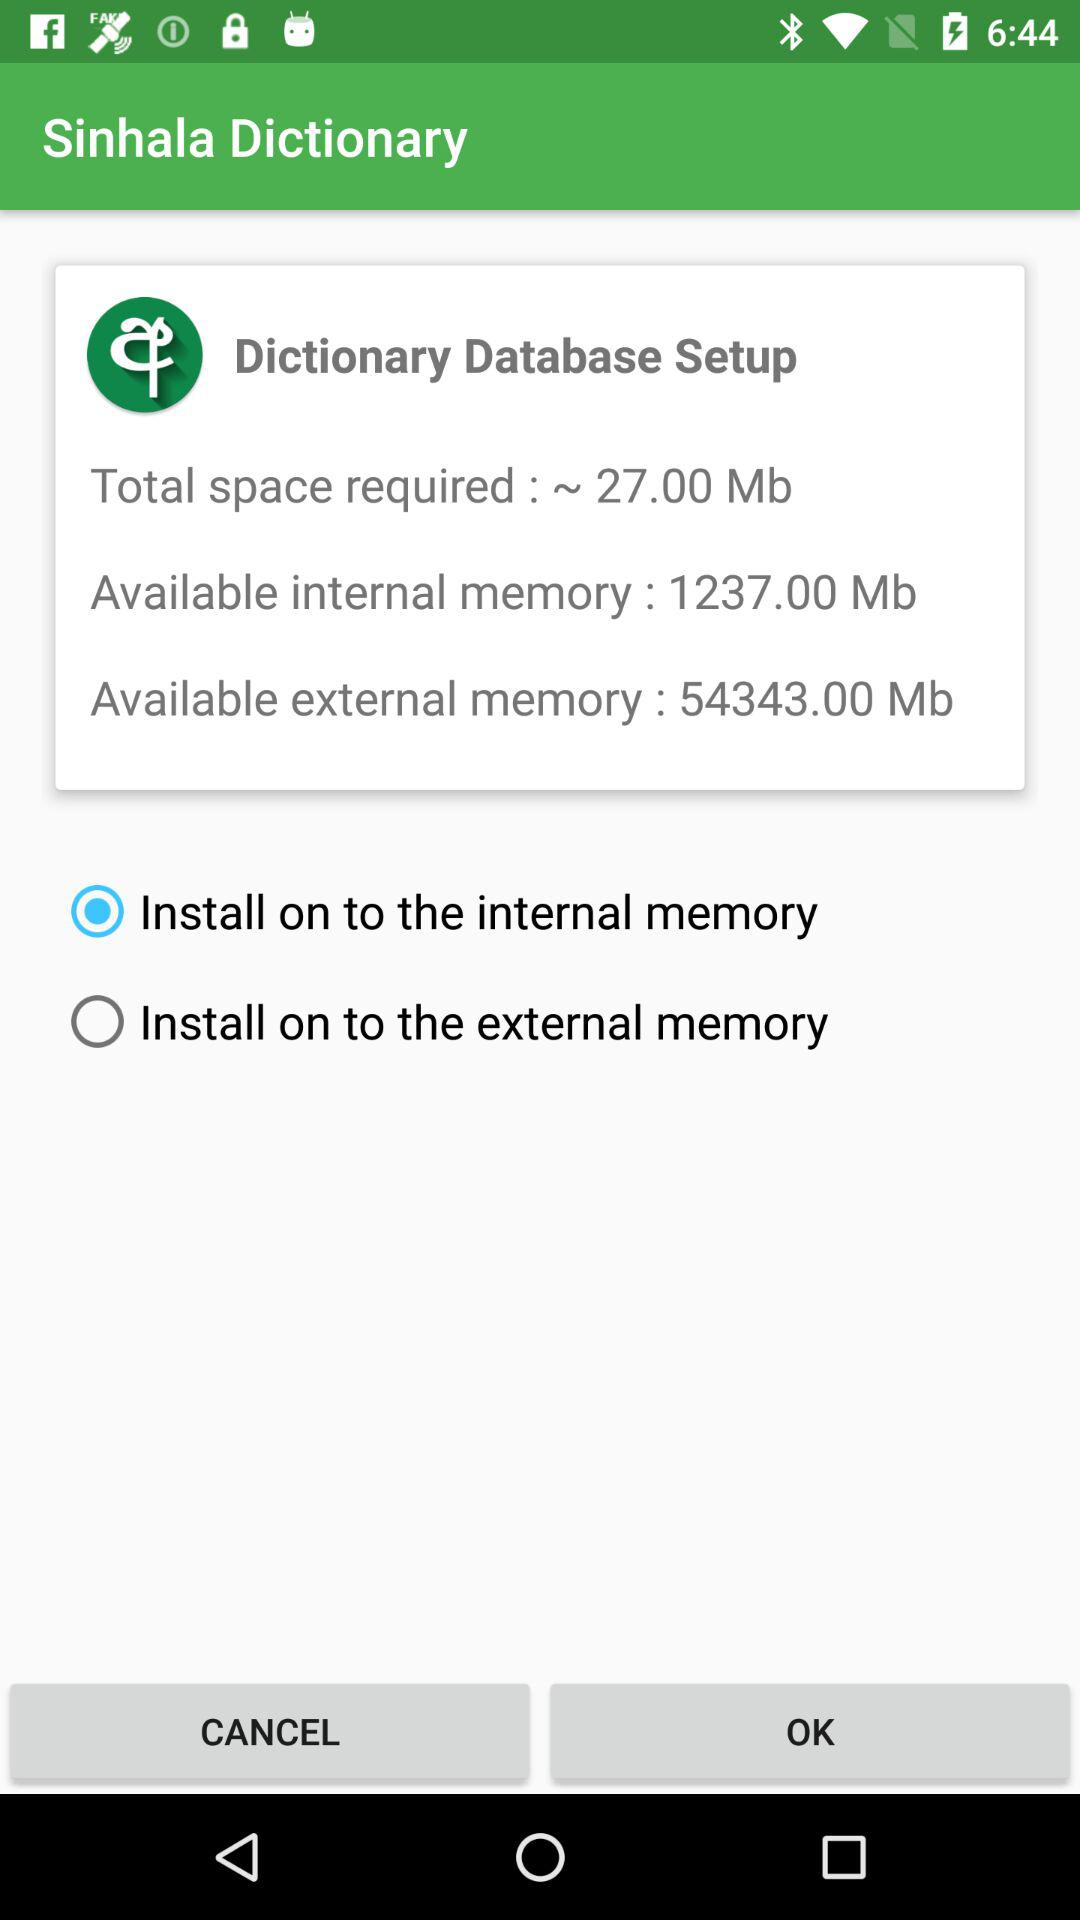How much external memory is available? The available external memory is 54343.00 Mb. 